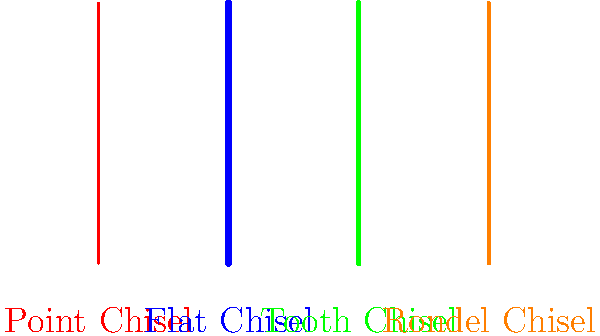Which of the illustrated chisels would be most effective for creating fine details and intricate patterns in stone carving? To answer this question, we need to consider the characteristics and uses of each chisel type:

1. Point Chisel (Red): This chisel has a sharp, pointed tip. It's used for:
   - Roughing out initial shapes
   - Creating texture
   - Making precise indentations

2. Flat Chisel (Blue): This chisel has a wide, flat edge. It's used for:
   - Smoothing surfaces
   - Creating straight lines and edges
   - Removing large amounts of material

3. Tooth Chisel (Green): This chisel has multiple points or teeth. It's used for:
   - Creating rough textures
   - Removing material quickly
   - Preparing surfaces for finer work

4. Rondel Chisel (Orange): This chisel has a rounded edge. It's used for:
   - Creating curved lines and shapes
   - Smoothing concave surfaces
   - Carving rounded details

For creating fine details and intricate patterns, we need a tool that allows for precise control and can create small, accurate marks. Among these options, the Point Chisel is best suited for this purpose. Its sharp, pointed tip allows for the creation of fine lines, small indentations, and intricate details that would be difficult to achieve with the other chisels.
Answer: Point Chisel 